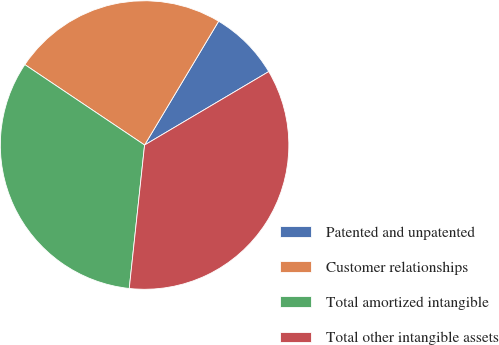<chart> <loc_0><loc_0><loc_500><loc_500><pie_chart><fcel>Patented and unpatented<fcel>Customer relationships<fcel>Total amortized intangible<fcel>Total other intangible assets<nl><fcel>7.92%<fcel>24.17%<fcel>32.72%<fcel>35.2%<nl></chart> 